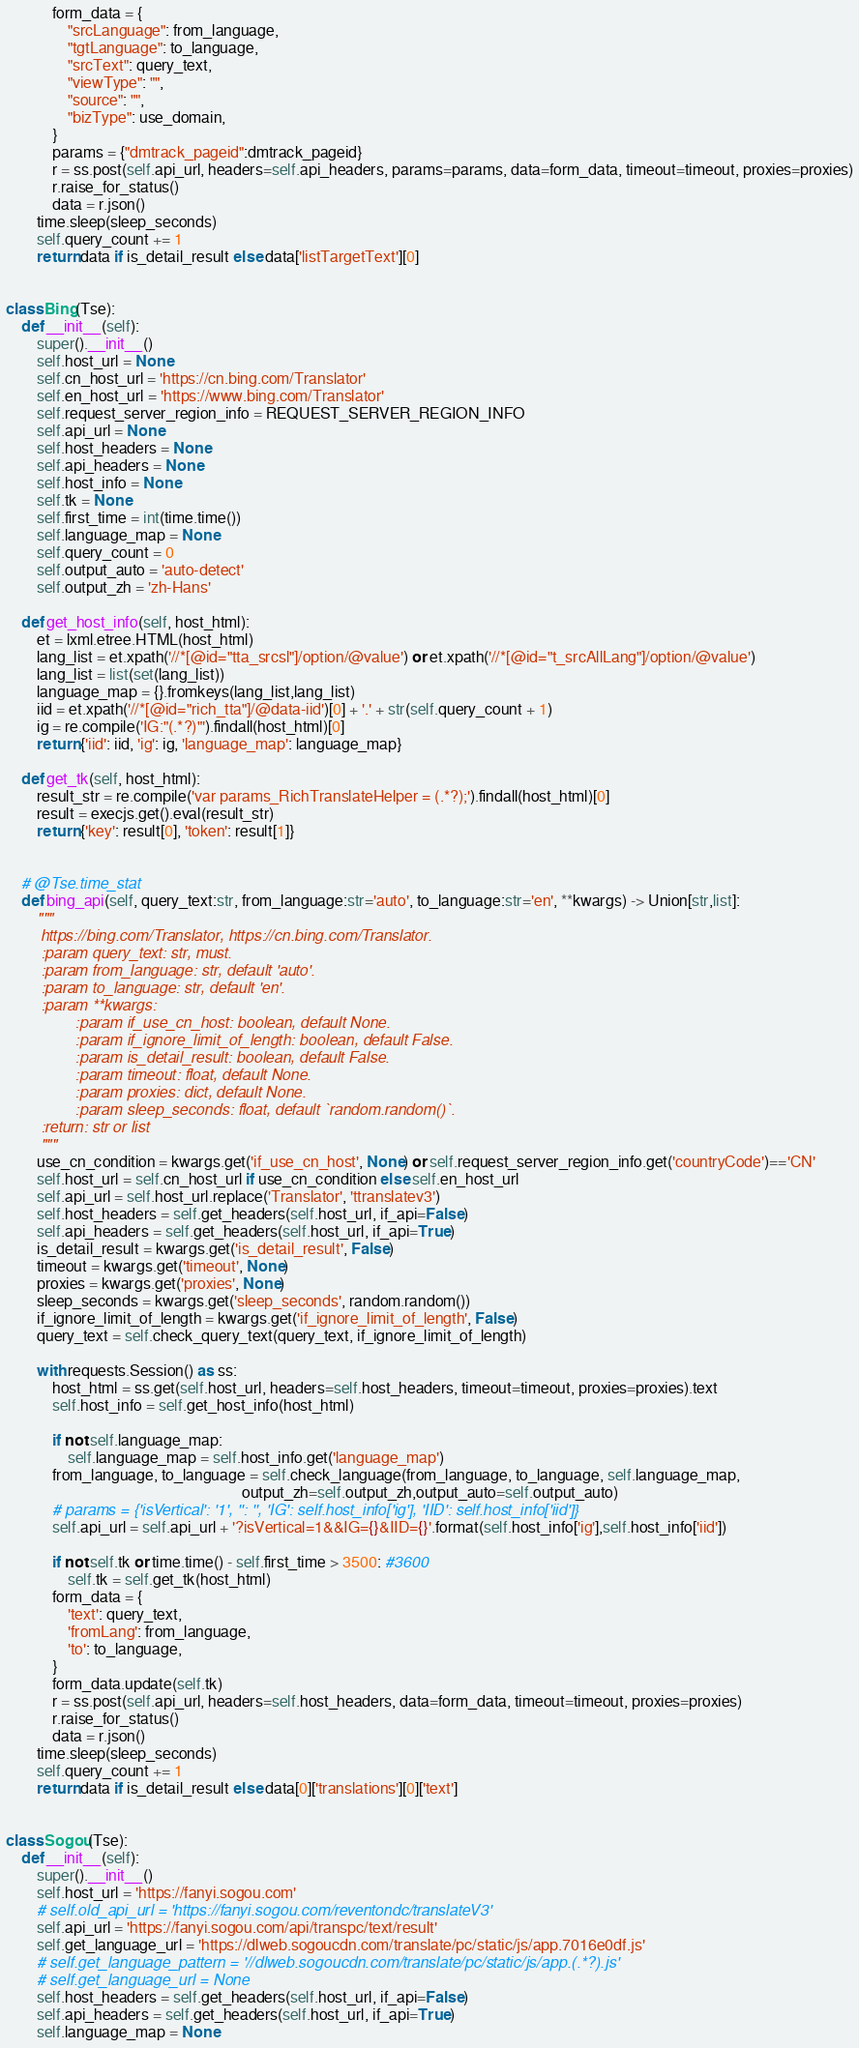Convert code to text. <code><loc_0><loc_0><loc_500><loc_500><_Python_>            form_data = {
                "srcLanguage": from_language,
                "tgtLanguage": to_language,
                "srcText": query_text,
                "viewType": "",
                "source": "",
                "bizType": use_domain,
            }
            params = {"dmtrack_pageid":dmtrack_pageid}
            r = ss.post(self.api_url, headers=self.api_headers, params=params, data=form_data, timeout=timeout, proxies=proxies)
            r.raise_for_status()
            data = r.json()
        time.sleep(sleep_seconds)
        self.query_count += 1
        return data if is_detail_result else data['listTargetText'][0]


class Bing(Tse):
    def __init__(self):
        super().__init__()
        self.host_url = None
        self.cn_host_url = 'https://cn.bing.com/Translator'
        self.en_host_url = 'https://www.bing.com/Translator'
        self.request_server_region_info = REQUEST_SERVER_REGION_INFO
        self.api_url = None
        self.host_headers = None
        self.api_headers = None
        self.host_info = None
        self.tk = None
        self.first_time = int(time.time())
        self.language_map = None
        self.query_count = 0
        self.output_auto = 'auto-detect'
        self.output_zh = 'zh-Hans'
    
    def get_host_info(self, host_html):
        et = lxml.etree.HTML(host_html)
        lang_list = et.xpath('//*[@id="tta_srcsl"]/option/@value') or et.xpath('//*[@id="t_srcAllLang"]/option/@value')
        lang_list = list(set(lang_list))
        language_map = {}.fromkeys(lang_list,lang_list)
        iid = et.xpath('//*[@id="rich_tta"]/@data-iid')[0] + '.' + str(self.query_count + 1)
        ig = re.compile('IG:"(.*?)"').findall(host_html)[0]
        return {'iid': iid, 'ig': ig, 'language_map': language_map}

    def get_tk(self, host_html):
        result_str = re.compile('var params_RichTranslateHelper = (.*?);').findall(host_html)[0]
        result = execjs.get().eval(result_str)
        return {'key': result[0], 'token': result[1]}


    # @Tse.time_stat
    def bing_api(self, query_text:str, from_language:str='auto', to_language:str='en', **kwargs) -> Union[str,list]:
        """
        https://bing.com/Translator, https://cn.bing.com/Translator.
        :param query_text: str, must.
        :param from_language: str, default 'auto'.
        :param to_language: str, default 'en'.
        :param **kwargs:
                :param if_use_cn_host: boolean, default None.
                :param if_ignore_limit_of_length: boolean, default False.
                :param is_detail_result: boolean, default False.
                :param timeout: float, default None.
                :param proxies: dict, default None.
                :param sleep_seconds: float, default `random.random()`.
        :return: str or list
        """
        use_cn_condition = kwargs.get('if_use_cn_host', None) or self.request_server_region_info.get('countryCode')=='CN'
        self.host_url = self.cn_host_url if use_cn_condition else self.en_host_url
        self.api_url = self.host_url.replace('Translator', 'ttranslatev3')
        self.host_headers = self.get_headers(self.host_url, if_api=False)
        self.api_headers = self.get_headers(self.host_url, if_api=True)
        is_detail_result = kwargs.get('is_detail_result', False)
        timeout = kwargs.get('timeout', None)
        proxies = kwargs.get('proxies', None)
        sleep_seconds = kwargs.get('sleep_seconds', random.random())
        if_ignore_limit_of_length = kwargs.get('if_ignore_limit_of_length', False)
        query_text = self.check_query_text(query_text, if_ignore_limit_of_length)
    
        with requests.Session() as ss:
            host_html = ss.get(self.host_url, headers=self.host_headers, timeout=timeout, proxies=proxies).text
            self.host_info = self.get_host_info(host_html)

            if not self.language_map:
                self.language_map = self.host_info.get('language_map')
            from_language, to_language = self.check_language(from_language, to_language, self.language_map,
                                                             output_zh=self.output_zh,output_auto=self.output_auto)
            # params = {'isVertical': '1', '': '', 'IG': self.host_info['ig'], 'IID': self.host_info['iid']}
            self.api_url = self.api_url + '?isVertical=1&&IG={}&IID={}'.format(self.host_info['ig'],self.host_info['iid'])

            if not self.tk or time.time() - self.first_time > 3500: #3600
                self.tk = self.get_tk(host_html)
            form_data = {
                'text': query_text,
                'fromLang': from_language,
                'to': to_language,
            }
            form_data.update(self.tk)
            r = ss.post(self.api_url, headers=self.host_headers, data=form_data, timeout=timeout, proxies=proxies)
            r.raise_for_status()
            data = r.json()
        time.sleep(sleep_seconds)
        self.query_count += 1
        return data if is_detail_result else data[0]['translations'][0]['text']


class Sogou(Tse):
    def __init__(self):
        super().__init__()
        self.host_url = 'https://fanyi.sogou.com'
        # self.old_api_url = 'https://fanyi.sogou.com/reventondc/translateV3'
        self.api_url = 'https://fanyi.sogou.com/api/transpc/text/result'
        self.get_language_url = 'https://dlweb.sogoucdn.com/translate/pc/static/js/app.7016e0df.js'
        # self.get_language_pattern = '//dlweb.sogoucdn.com/translate/pc/static/js/app.(.*?).js'
        # self.get_language_url = None
        self.host_headers = self.get_headers(self.host_url, if_api=False)
        self.api_headers = self.get_headers(self.host_url, if_api=True)
        self.language_map = None</code> 